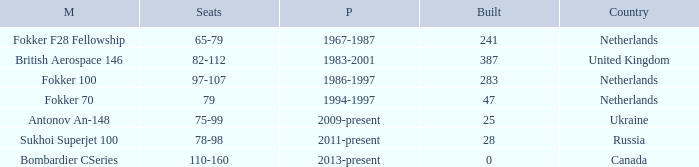How many cabins were built in the time between 1967-1987? 241.0. 